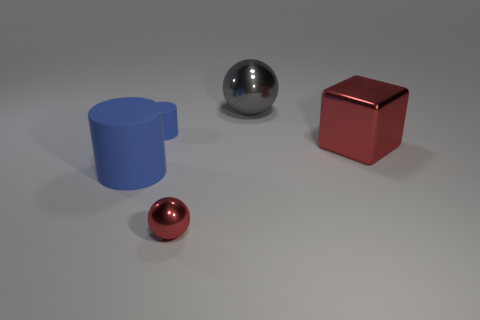Add 5 small brown objects. How many objects exist? 10 Subtract all cubes. How many objects are left? 4 Add 1 big cyan things. How many big cyan things exist? 1 Subtract 1 red blocks. How many objects are left? 4 Subtract all big red spheres. Subtract all large cylinders. How many objects are left? 4 Add 3 red metallic blocks. How many red metallic blocks are left? 4 